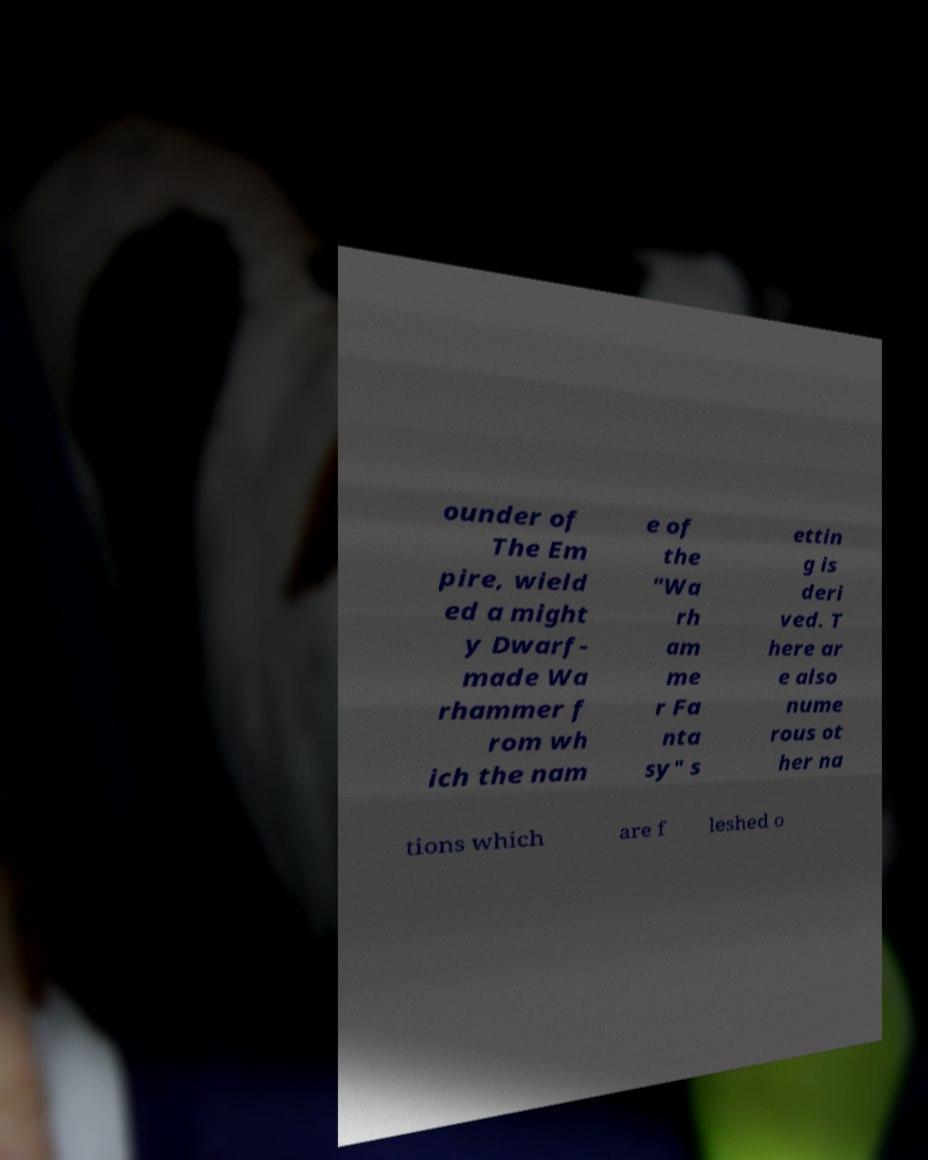Could you assist in decoding the text presented in this image and type it out clearly? ounder of The Em pire, wield ed a might y Dwarf- made Wa rhammer f rom wh ich the nam e of the "Wa rh am me r Fa nta sy" s ettin g is deri ved. T here ar e also nume rous ot her na tions which are f leshed o 